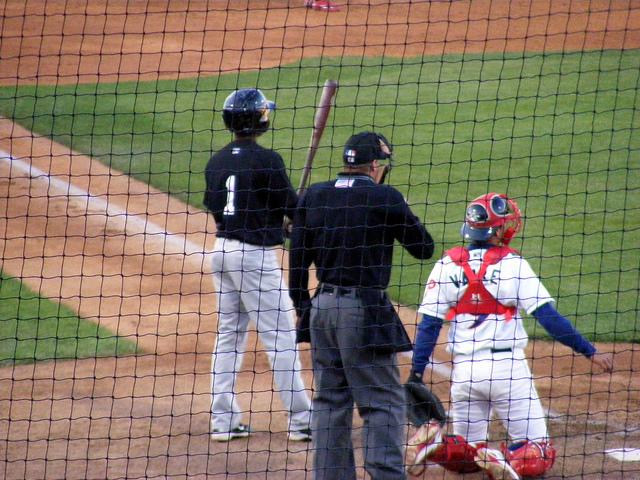Is it his turn to bat?
Quick response, please. Yes. What game are the men playing?
Quick response, please. Baseball. What is creating the appearance of a grid over the entire image?
Be succinct. Net. 